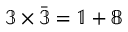<formula> <loc_0><loc_0><loc_500><loc_500>\mathbb { 3 } \times { \bar { \mathbb { 3 } } } = \mathbb { 1 } + \mathbb { 8 }</formula> 